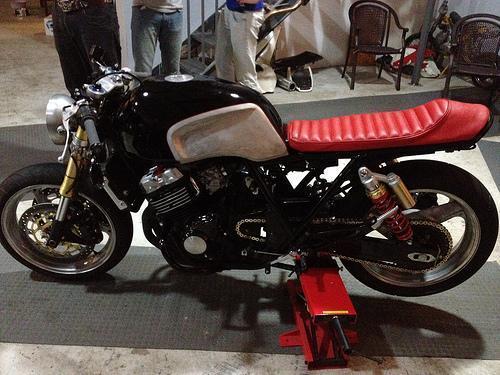How many wheels does the motorcycle have?
Give a very brief answer. 2. How many chairs on the background?
Give a very brief answer. 2. 